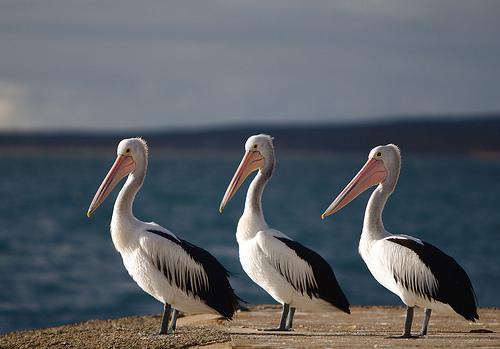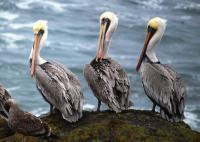The first image is the image on the left, the second image is the image on the right. Assess this claim about the two images: "Three birds are perched on flat planks of a deck.". Correct or not? Answer yes or no. Yes. The first image is the image on the left, the second image is the image on the right. Analyze the images presented: Is the assertion "Each image contains three left-facing pelicans posed in a row." valid? Answer yes or no. Yes. 